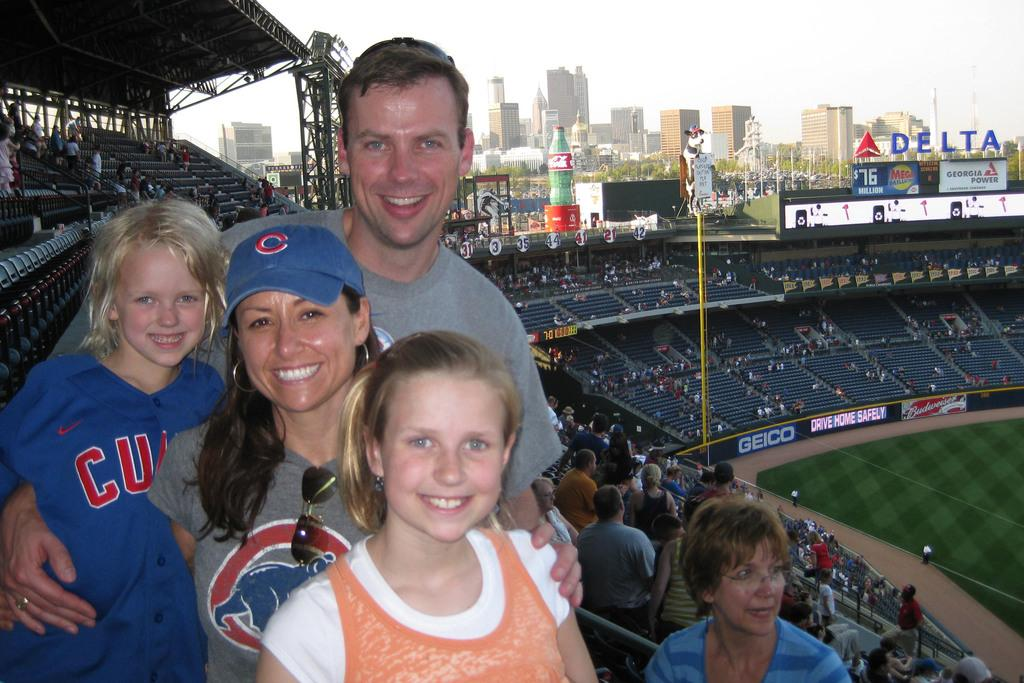<image>
Present a compact description of the photo's key features. a family with a little girl wearing a 'cubs' jersey 